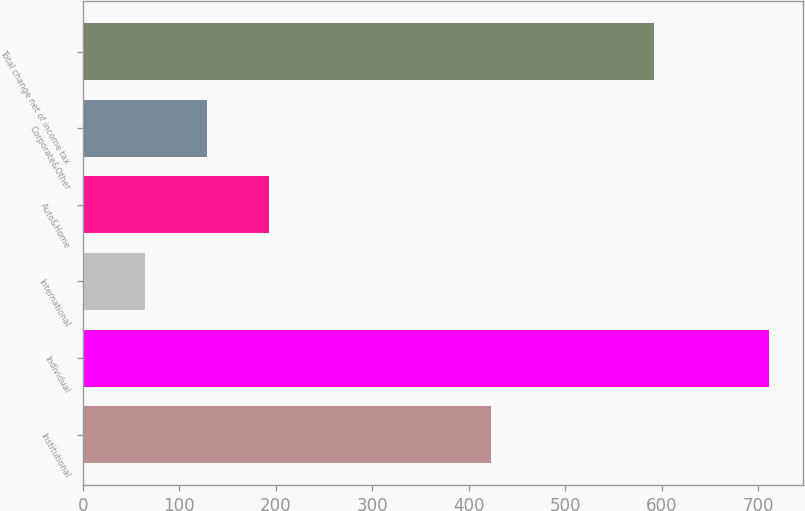Convert chart. <chart><loc_0><loc_0><loc_500><loc_500><bar_chart><fcel>Institutional<fcel>Individual<fcel>International<fcel>Auto&Home<fcel>Corporate&Other<fcel>Total change net of income tax<nl><fcel>423<fcel>711<fcel>64<fcel>193.4<fcel>128.7<fcel>592<nl></chart> 